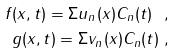Convert formula to latex. <formula><loc_0><loc_0><loc_500><loc_500>f ( x , t ) = \Sigma u _ { n } ( x ) C _ { n } ( t ) \ , \\ g ( x , t ) = \Sigma v _ { n } ( x ) C _ { n } ( t ) \ ,</formula> 